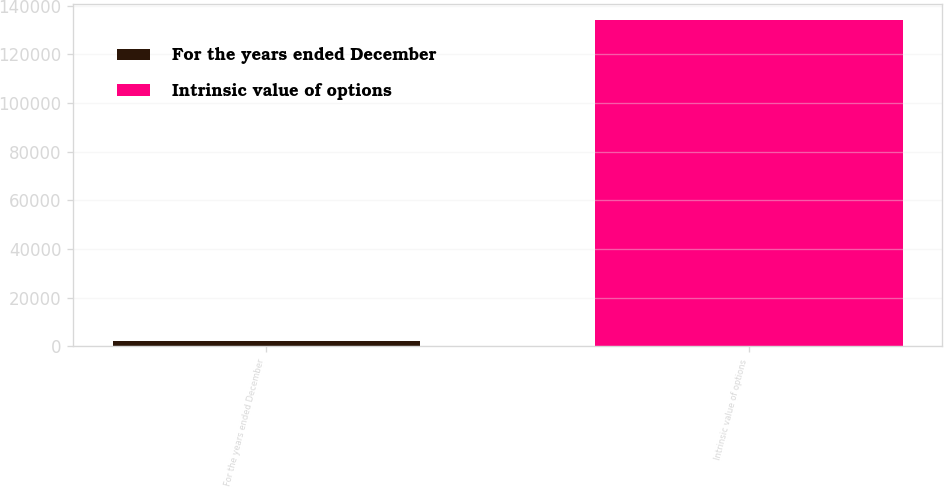Convert chart to OTSL. <chart><loc_0><loc_0><loc_500><loc_500><bar_chart><fcel>For the years ended December<fcel>Intrinsic value of options<nl><fcel>2014<fcel>133948<nl></chart> 